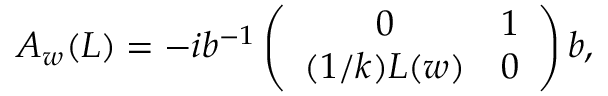<formula> <loc_0><loc_0><loc_500><loc_500>A _ { w } ( L ) = - i b ^ { - 1 } \left ( \begin{array} { c c } { 0 } & { 1 } \\ { ( 1 / k ) L ( w ) } & { 0 } \end{array} \right ) b ,</formula> 